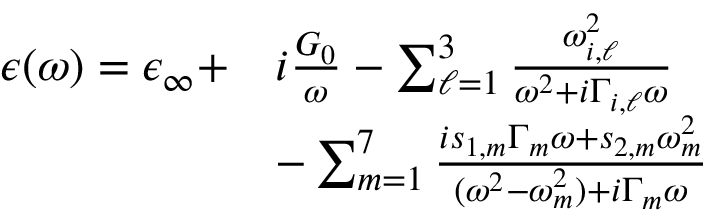Convert formula to latex. <formula><loc_0><loc_0><loc_500><loc_500>\begin{array} { r } { \begin{array} { r l } { \epsilon ( \omega ) = \epsilon _ { \infty } + } & { i \frac { G _ { 0 } } { \omega } - \sum _ { \ell = 1 } ^ { 3 } \frac { \omega _ { i , \ell } ^ { 2 } } { \omega ^ { 2 } + i \Gamma _ { i , \ell } \omega } } \\ & { - \sum _ { m = 1 } ^ { 7 } \frac { i s _ { 1 , m } \Gamma _ { m } \omega + s _ { 2 , m } \omega _ { m } ^ { 2 } } { ( \omega ^ { 2 } - \omega _ { m } ^ { 2 } ) + i \Gamma _ { m } \omega } } \end{array} } \end{array}</formula> 